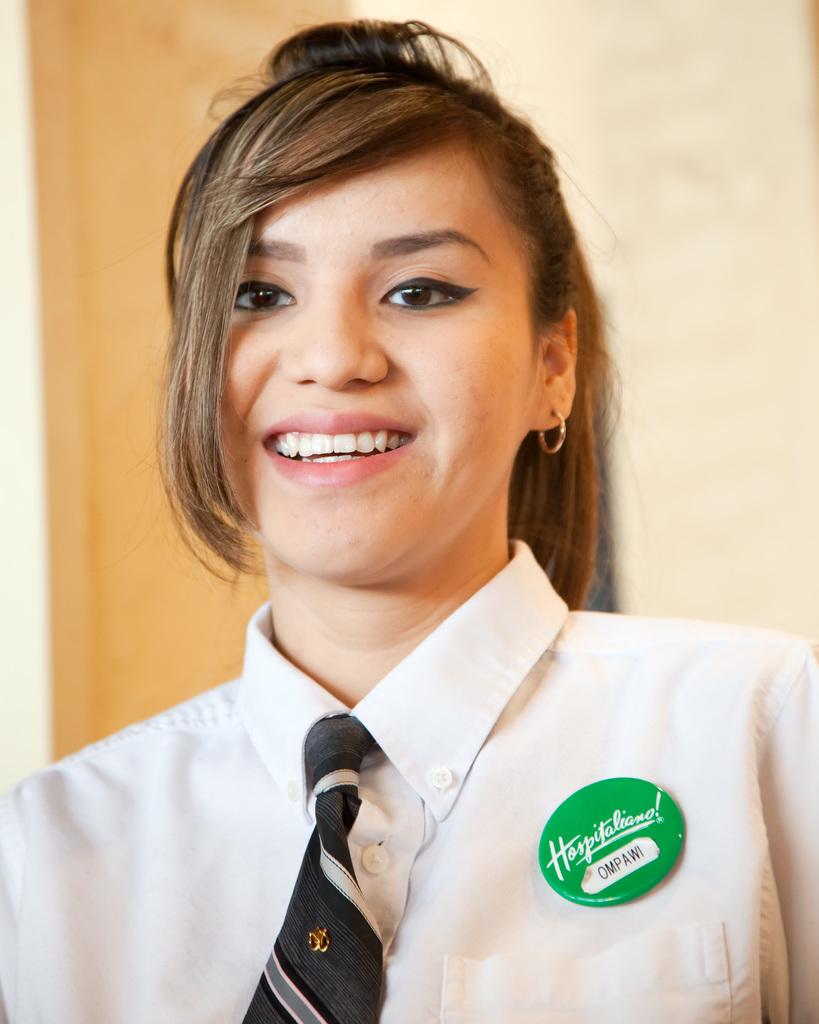What ison the logo?
Your response must be concise. Hospitaliano!. What name is on the white sticker on her green button?
Offer a very short reply. Ompawi. 